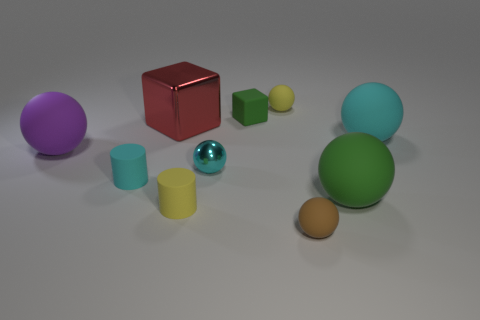There is a sphere in front of the large green sphere; what is its color?
Make the answer very short. Brown. How many blocks are either yellow rubber objects or brown metal things?
Your response must be concise. 0. What size is the green thing that is in front of the cyan ball on the right side of the green rubber block?
Provide a short and direct response. Large. There is a matte cube; is it the same color as the large rubber object in front of the cyan matte cylinder?
Keep it short and to the point. Yes. There is a tiny brown matte sphere; what number of big balls are to the right of it?
Your answer should be very brief. 2. Are there fewer small rubber cylinders than tiny yellow cubes?
Ensure brevity in your answer.  No. How big is the matte sphere that is both behind the cyan shiny sphere and right of the small yellow ball?
Give a very brief answer. Large. There is a big sphere left of the small brown matte thing; is it the same color as the shiny cube?
Make the answer very short. No. Is the number of tiny spheres that are right of the tiny cyan shiny sphere less than the number of cyan rubber cylinders?
Offer a very short reply. No. What is the shape of the big green object that is made of the same material as the brown thing?
Your response must be concise. Sphere. 